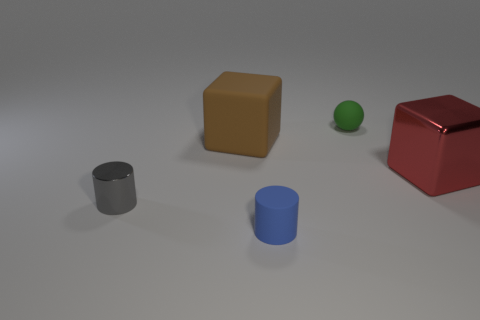What is the color of the tiny rubber object in front of the metallic object that is behind the small metal object?
Your answer should be compact. Blue. Is there another shiny cylinder that has the same color as the metal cylinder?
Provide a succinct answer. No. What is the shape of the blue matte thing that is the same size as the green matte ball?
Offer a very short reply. Cylinder. There is a rubber thing that is in front of the gray cylinder; what number of cubes are right of it?
Ensure brevity in your answer.  1. Is the color of the rubber cylinder the same as the large metal object?
Ensure brevity in your answer.  No. How many other objects are the same material as the gray thing?
Give a very brief answer. 1. What shape is the metal thing that is on the right side of the cube that is behind the big metal block?
Ensure brevity in your answer.  Cube. There is a ball behind the brown rubber cube; how big is it?
Your answer should be compact. Small. Is the material of the big red thing the same as the tiny gray cylinder?
Keep it short and to the point. Yes. There is a small blue object that is the same material as the tiny ball; what is its shape?
Offer a terse response. Cylinder. 